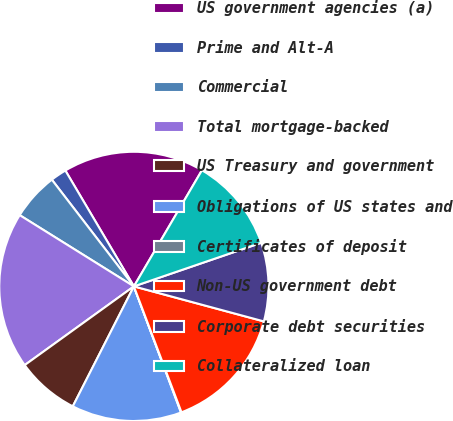<chart> <loc_0><loc_0><loc_500><loc_500><pie_chart><fcel>US government agencies (a)<fcel>Prime and Alt-A<fcel>Commercial<fcel>Total mortgage-backed<fcel>US Treasury and government<fcel>Obligations of US states and<fcel>Certificates of deposit<fcel>Non-US government debt<fcel>Corporate debt securities<fcel>Collateralized loan<nl><fcel>16.94%<fcel>1.93%<fcel>5.69%<fcel>18.82%<fcel>7.56%<fcel>13.19%<fcel>0.06%<fcel>15.06%<fcel>9.44%<fcel>11.31%<nl></chart> 